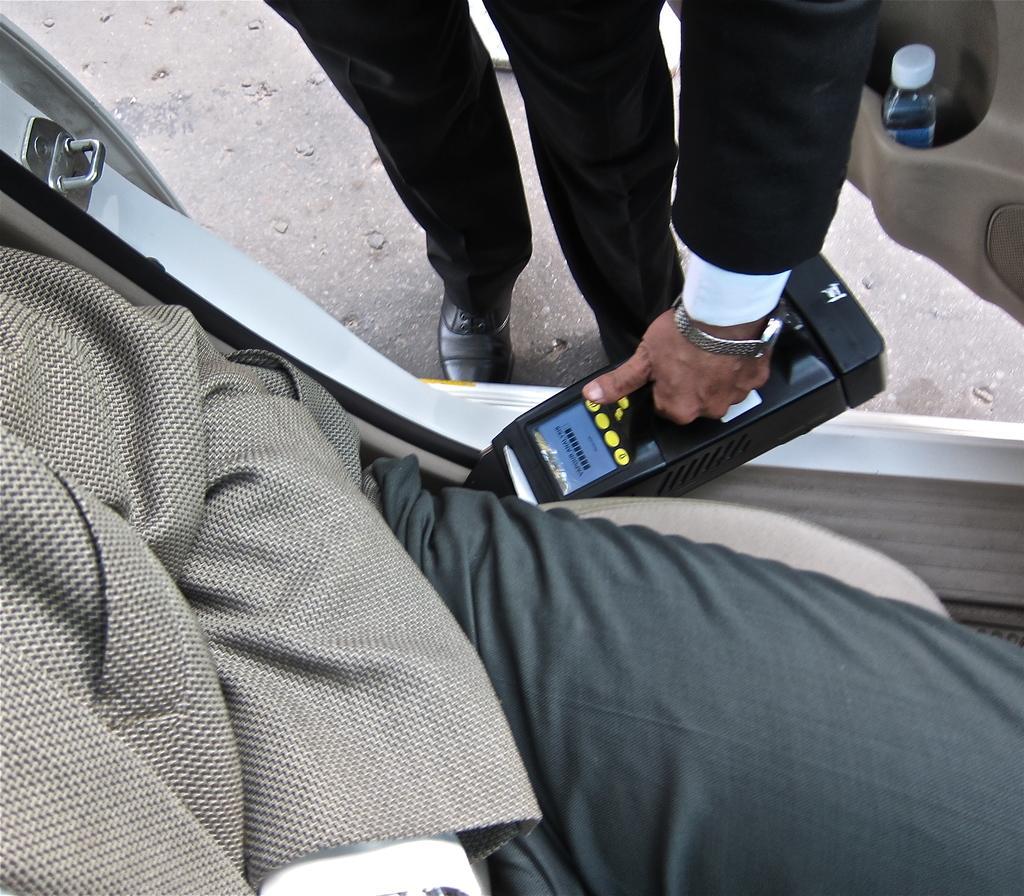How would you summarize this image in a sentence or two? In this picture we can see two person's, a person at the bottom is sitting in a vehicle, this person is holding something, we can see a bottle here. 